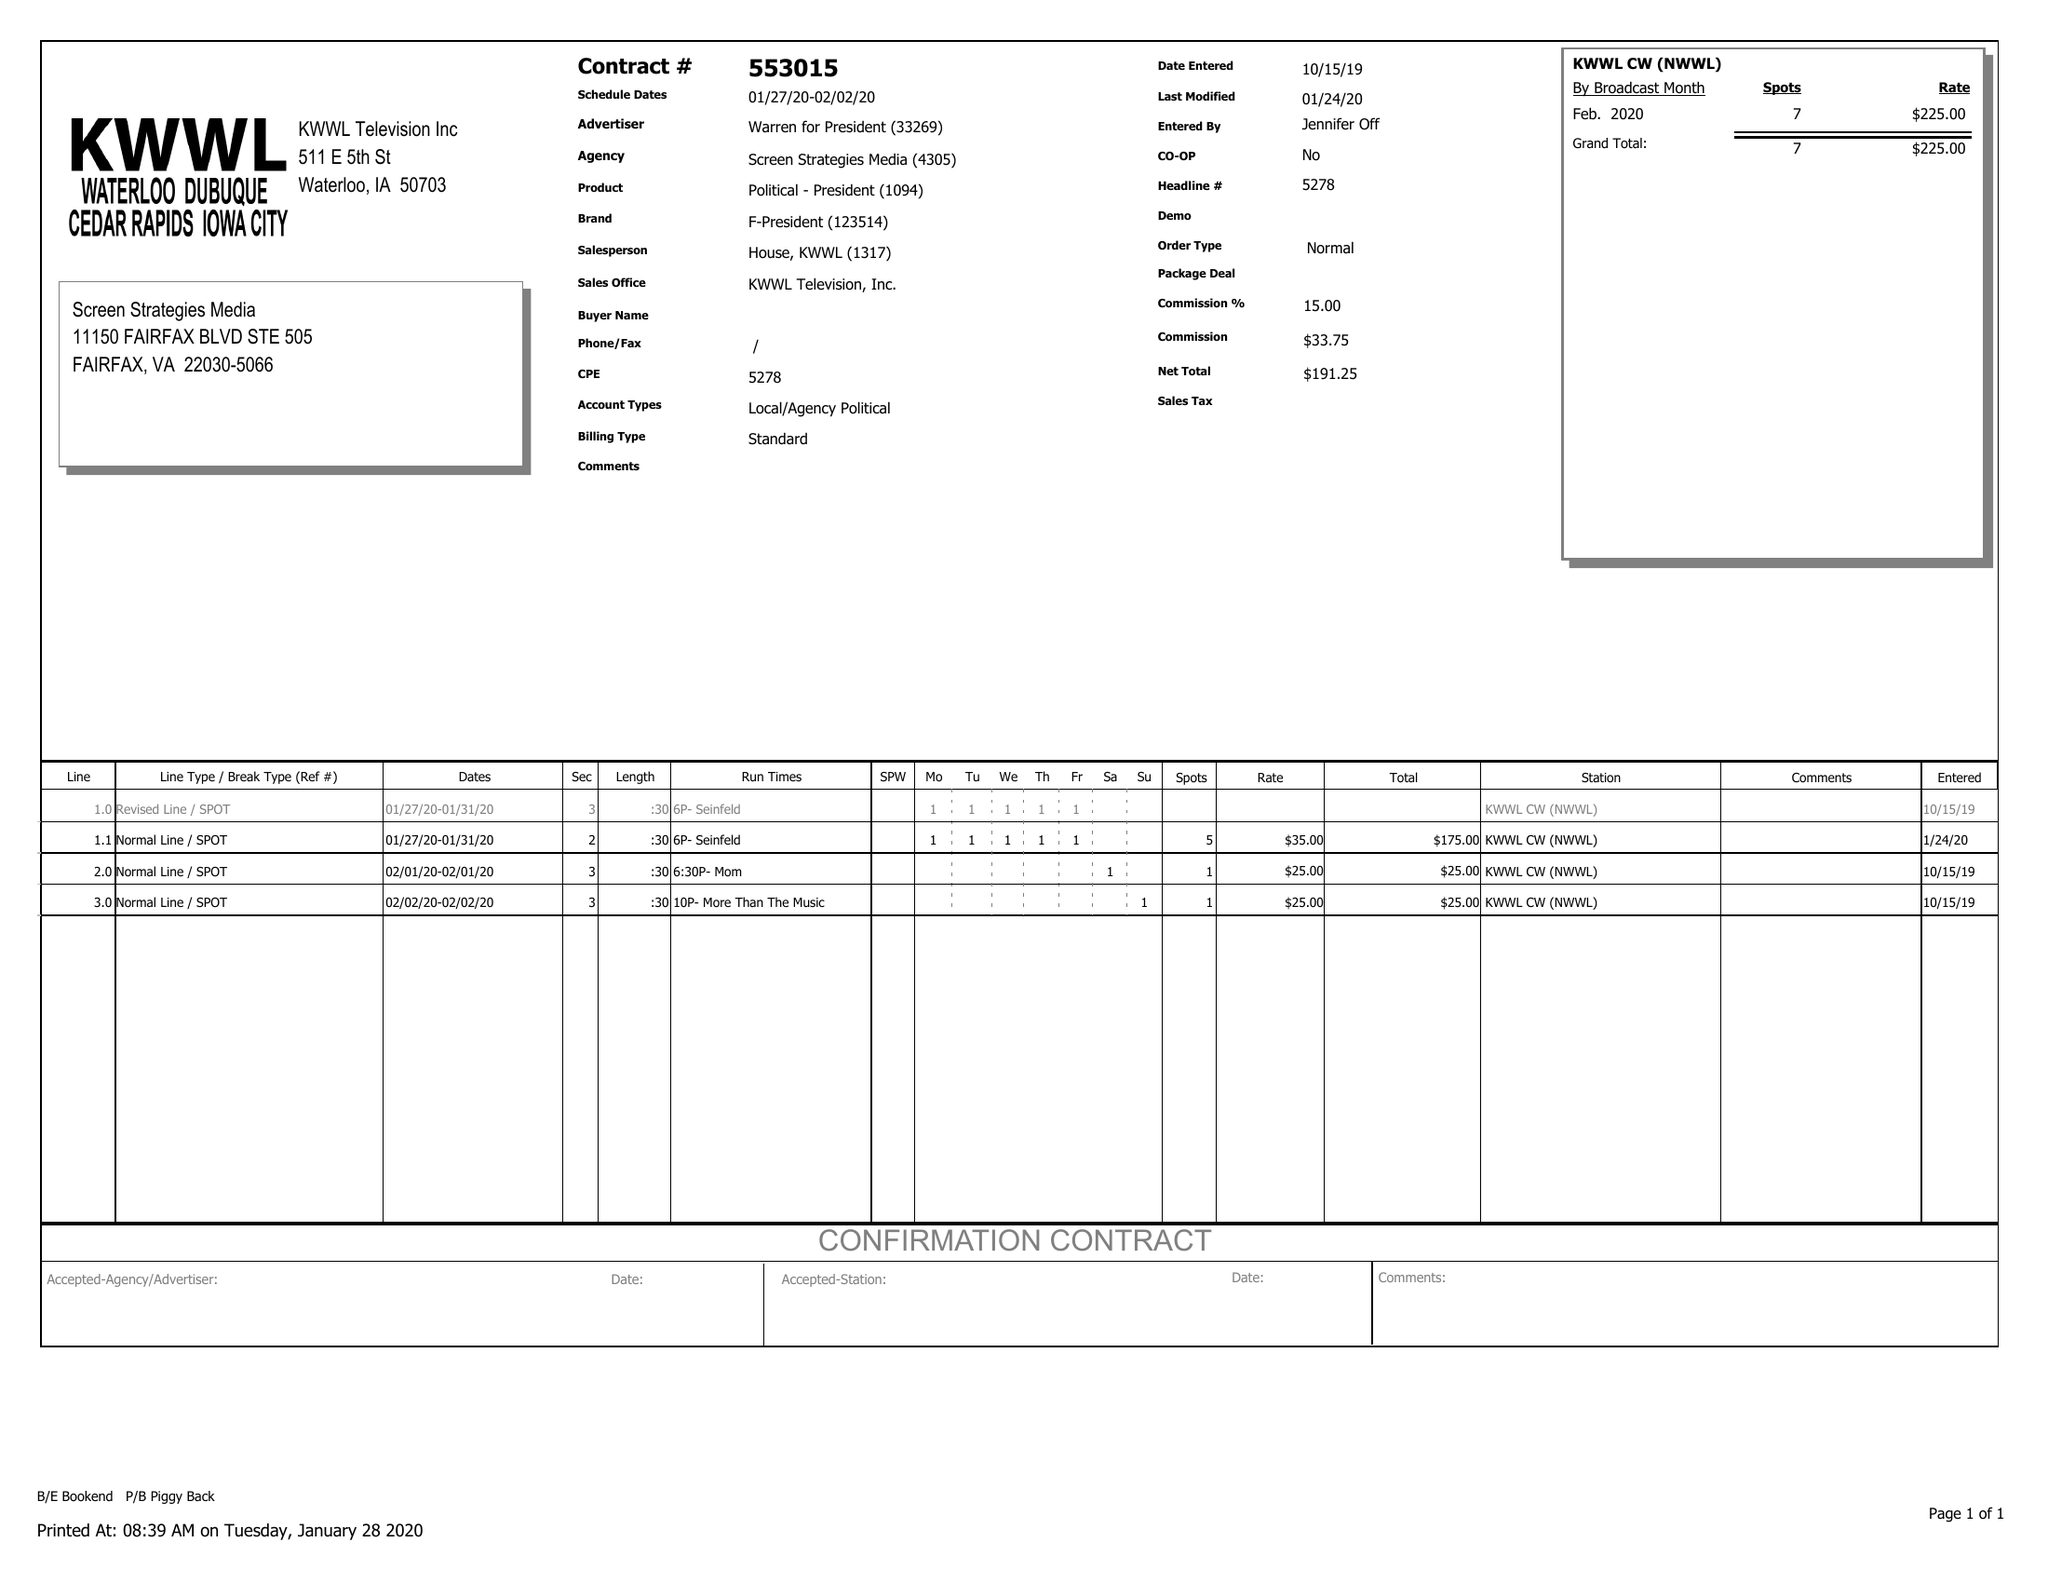What is the value for the flight_to?
Answer the question using a single word or phrase. 02/02/20 